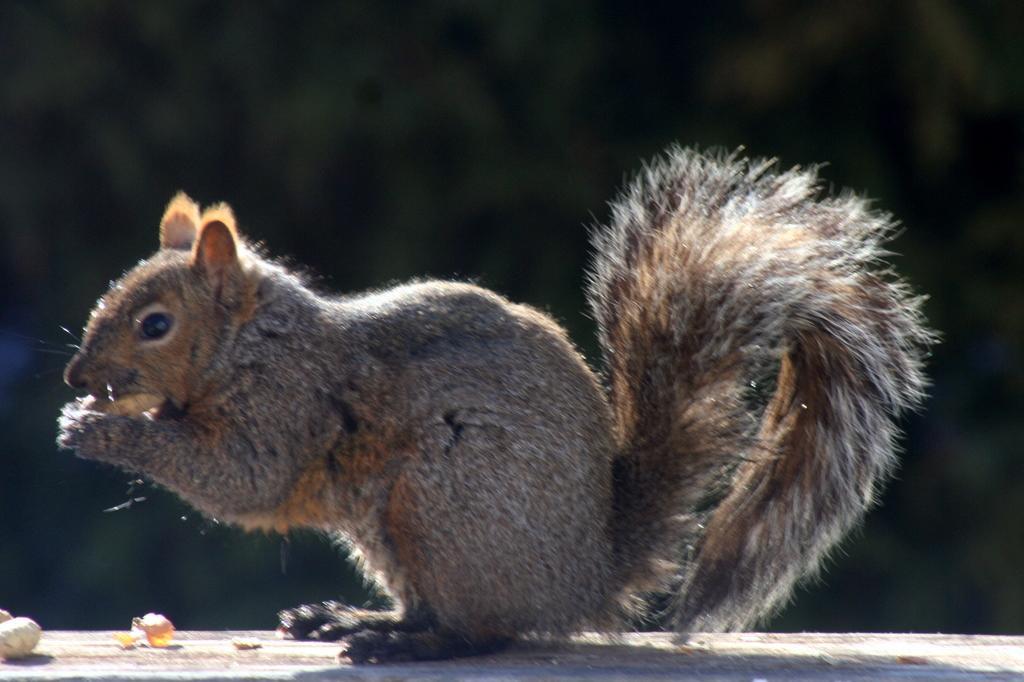In one or two sentences, can you explain what this image depicts? In the middle of the image, there is a squirrel holding an object on a surface, on which there are some objects. And the background is dark in color. 